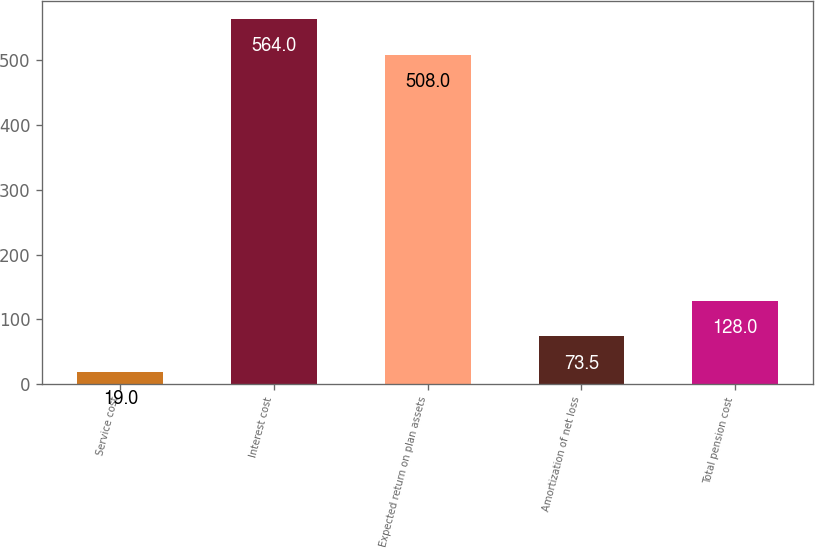Convert chart to OTSL. <chart><loc_0><loc_0><loc_500><loc_500><bar_chart><fcel>Service cost<fcel>Interest cost<fcel>Expected return on plan assets<fcel>Amortization of net loss<fcel>Total pension cost<nl><fcel>19<fcel>564<fcel>508<fcel>73.5<fcel>128<nl></chart> 